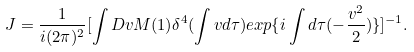Convert formula to latex. <formula><loc_0><loc_0><loc_500><loc_500>J = \frac { 1 } { i ( 2 \pi ) ^ { 2 } } [ \int D v M ( 1 ) \delta ^ { 4 } ( \int v d \tau ) e x p \{ i \int d \tau ( - \frac { v ^ { 2 } } { 2 } ) \} ] ^ { - 1 } .</formula> 